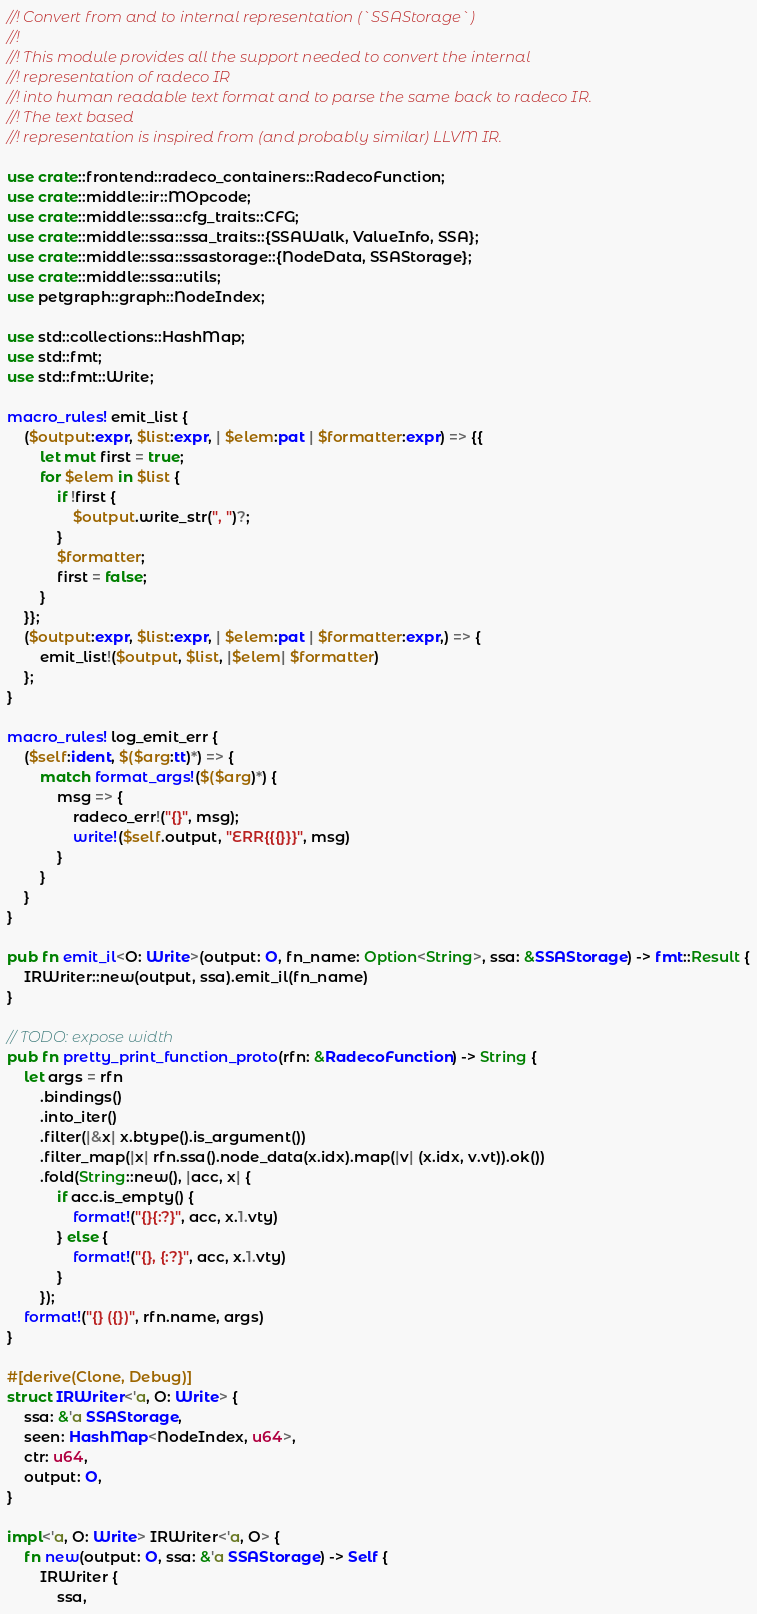<code> <loc_0><loc_0><loc_500><loc_500><_Rust_>//! Convert from and to internal representation (`SSAStorage`)
//!
//! This module provides all the support needed to convert the internal
//! representation of radeco IR
//! into human readable text format and to parse the same back to radeco IR.
//! The text based
//! representation is inspired from (and probably similar) LLVM IR.

use crate::frontend::radeco_containers::RadecoFunction;
use crate::middle::ir::MOpcode;
use crate::middle::ssa::cfg_traits::CFG;
use crate::middle::ssa::ssa_traits::{SSAWalk, ValueInfo, SSA};
use crate::middle::ssa::ssastorage::{NodeData, SSAStorage};
use crate::middle::ssa::utils;
use petgraph::graph::NodeIndex;

use std::collections::HashMap;
use std::fmt;
use std::fmt::Write;

macro_rules! emit_list {
    ($output:expr, $list:expr, | $elem:pat | $formatter:expr) => {{
        let mut first = true;
        for $elem in $list {
            if !first {
                $output.write_str(", ")?;
            }
            $formatter;
            first = false;
        }
    }};
    ($output:expr, $list:expr, | $elem:pat | $formatter:expr,) => {
        emit_list!($output, $list, |$elem| $formatter)
    };
}

macro_rules! log_emit_err {
    ($self:ident, $($arg:tt)*) => {
        match format_args!($($arg)*) {
            msg => {
                radeco_err!("{}", msg);
                write!($self.output, "ERR{{{}}}", msg)
            }
        }
    }
}

pub fn emit_il<O: Write>(output: O, fn_name: Option<String>, ssa: &SSAStorage) -> fmt::Result {
    IRWriter::new(output, ssa).emit_il(fn_name)
}

// TODO: expose width
pub fn pretty_print_function_proto(rfn: &RadecoFunction) -> String {
    let args = rfn
        .bindings()
        .into_iter()
        .filter(|&x| x.btype().is_argument())
        .filter_map(|x| rfn.ssa().node_data(x.idx).map(|v| (x.idx, v.vt)).ok())
        .fold(String::new(), |acc, x| {
            if acc.is_empty() {
                format!("{}{:?}", acc, x.1.vty)
            } else {
                format!("{}, {:?}", acc, x.1.vty)
            }
        });
    format!("{} ({})", rfn.name, args)
}

#[derive(Clone, Debug)]
struct IRWriter<'a, O: Write> {
    ssa: &'a SSAStorage,
    seen: HashMap<NodeIndex, u64>,
    ctr: u64,
    output: O,
}

impl<'a, O: Write> IRWriter<'a, O> {
    fn new(output: O, ssa: &'a SSAStorage) -> Self {
        IRWriter {
            ssa,</code> 